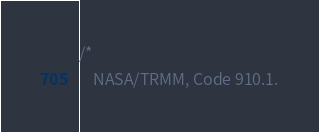<code> <loc_0><loc_0><loc_500><loc_500><_C_>/*
    NASA/TRMM, Code 910.1.</code> 